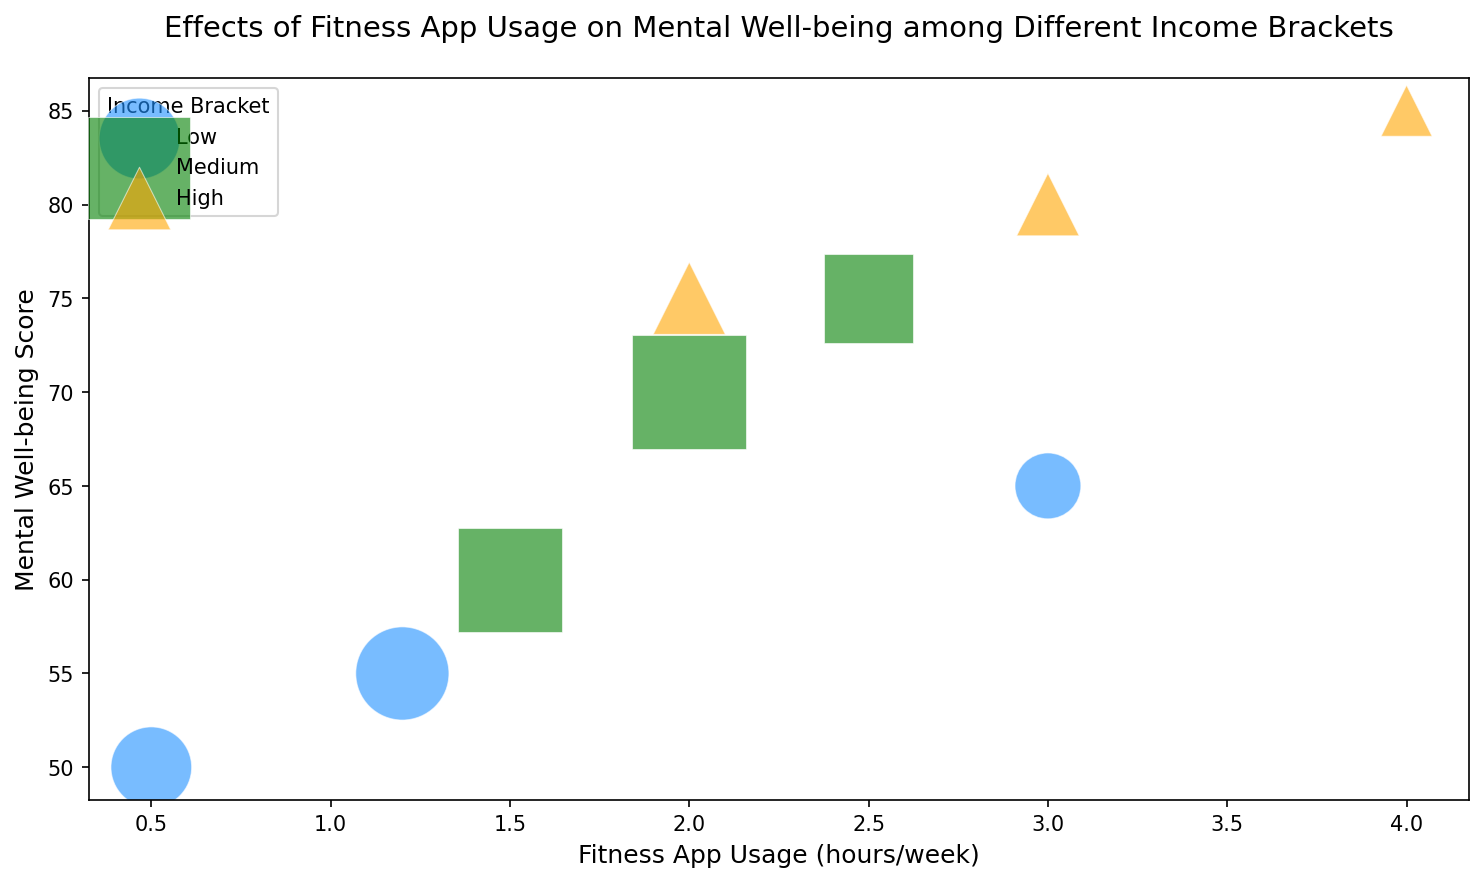What's the correlation between the hours of fitness app usage and mental well-being score for each income bracket? To determine the correlation, observe the trend within each income bracket by looking at the scatter plots: For Low Income, as app usage increases from 0.5 to 3.0 hours/week, the score appears to increase from 50 to 65. For Medium Income, as app usage increases from 1.5 to 2.5 hours/week, the score rises from 60 to 75. For High Income, increasing app usage from 2.0 to 4.0 hours/week boosts the score from 75 to 85. This indicates a positive correlation for each income bracket.
Answer: Positive for all brackets Which income bracket shows the highest mental well-being score? To determine the highest mental well-being score, look for the largest y-value. The High-income bracket shows the highest score of 85 at 4.0 hours/week.
Answer: High What is the range of mental well-being scores for the Medium income bracket? Identify the minimum and maximum mental well-being scores within the Medium income bracket. The scores are 60 to 75. Therefore, the range is 75 - 60 = 15.
Answer: 15 How does the population size vary among different income brackets for similar fitness app usage? Compare the bubble sizes for similar hours of app usage: For approximately 2.0 hours/week, Low has a population of 200 (largest), Medium has 250 (medium), and High has 120 (small).
Answer: Low > Medium > High for 2.0 hours/week What is the average mental well-being score for the Low-income bracket? Add the mental well-being scores of the Low-income bracket (55, 50, 65) and divide by the number of data points (3). (55 + 50 + 65) / 3 = 56.67.
Answer: 56.67 Compare the impact of fitness app usage on mental well-being between Low and High income brackets for the highest app usage values? For the highest fitness app usage, Low has 3.0 hours/week with a score of 65, and High has 4.0 hours/week with a score of 85. The increase in mental well-being score from Low to High is 85 - 65 = 20 points.
Answer: High has 20 points more What is the median mental well-being score for the entire dataset? Arrange all scores (50, 55, 60, 65, 70, 75, 75, 80, 85) in ascending order. The middle value (5th out of 9) is 70.
Answer: 70 Which income bracket has the smallest bubble on the plot and what does it represent? Identify the smallest bubble and check its associated data point. The smallest bubble is in the High-income bracket with a population size of 60.
Answer: High-income with 60 population If we consider only the data points with fitness app usage greater than 2.0 hours/week, which income bracket exhibits the highest mental well-being score? For usage > 2.0 hours/week, the scores are: Low (65), Medium (75), High (80, 85). The highest score is 85 in the High-income bracket.
Answer: High What is the difference in maximum mental well-being scores between Low and Medium income brackets? Identify the max scores: Low has 65, Medium has 75. Difference is 75 - 65 = 10.
Answer: 10 